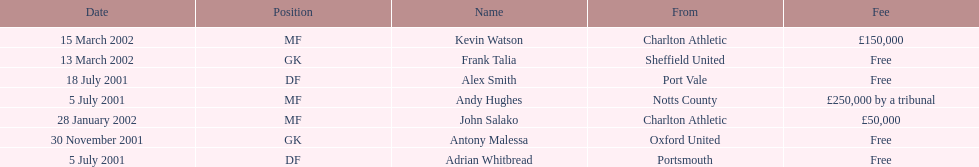Which transfer in was next after john salako's in 2002? Frank Talia. 